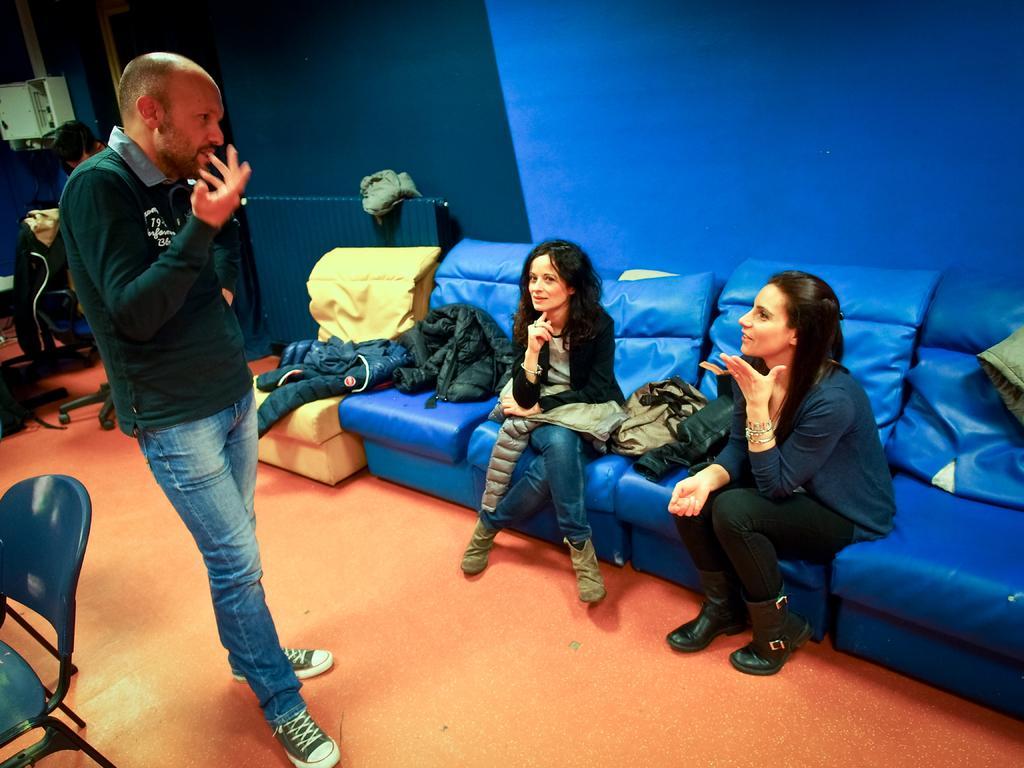Could you give a brief overview of what you see in this image? This is an inside view of a room. On the left side, I can see a man wearing t-shirt, jeans, standing and speaking something by looking at the women who are sitting on the couch which is in blue color. Along with these women few jackets are placed on this couch. At the back I can see a wall. Beside this man there is a chair. In the background, I can see another person and few chairs. 